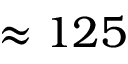Convert formula to latex. <formula><loc_0><loc_0><loc_500><loc_500>\approx 1 2 5</formula> 